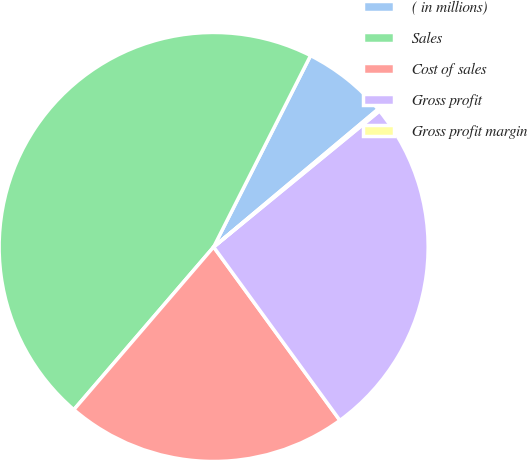Convert chart. <chart><loc_0><loc_0><loc_500><loc_500><pie_chart><fcel>( in millions)<fcel>Sales<fcel>Cost of sales<fcel>Gross profit<fcel>Gross profit margin<nl><fcel>6.44%<fcel>46.16%<fcel>21.31%<fcel>25.91%<fcel>0.17%<nl></chart> 